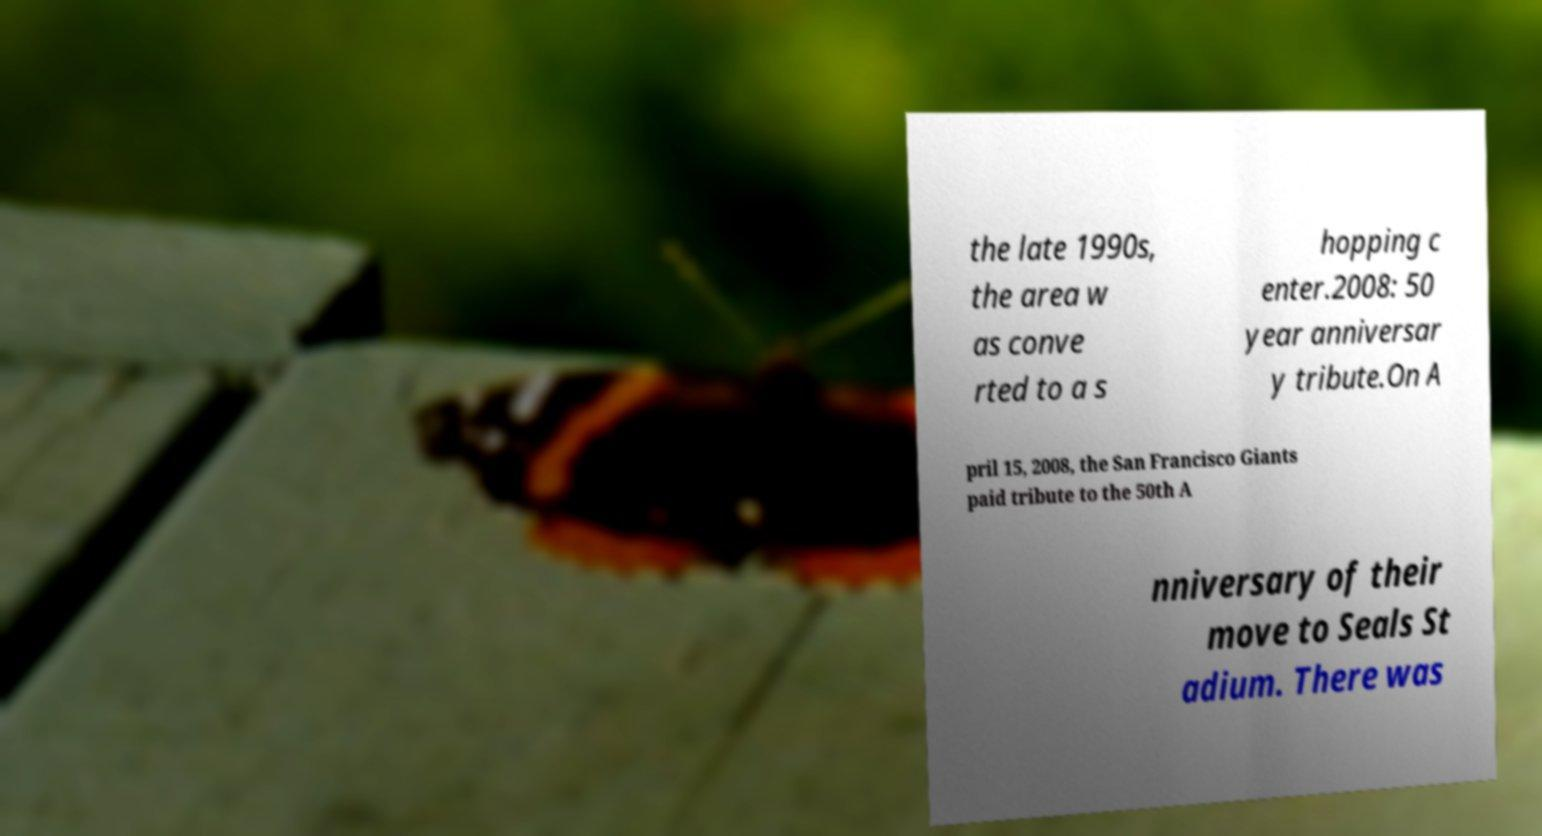For documentation purposes, I need the text within this image transcribed. Could you provide that? the late 1990s, the area w as conve rted to a s hopping c enter.2008: 50 year anniversar y tribute.On A pril 15, 2008, the San Francisco Giants paid tribute to the 50th A nniversary of their move to Seals St adium. There was 